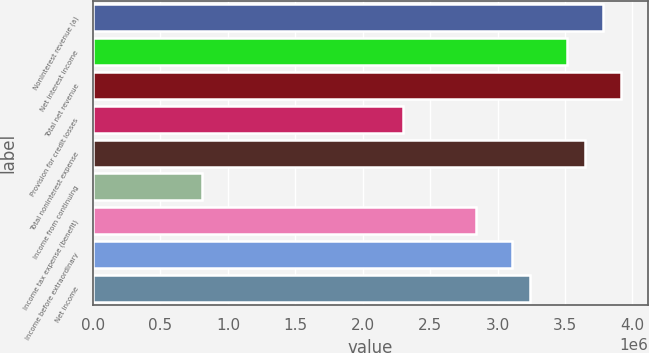Convert chart. <chart><loc_0><loc_0><loc_500><loc_500><bar_chart><fcel>Noninterest revenue (a)<fcel>Net interest income<fcel>Total net revenue<fcel>Provision for credit losses<fcel>Total noninterest expense<fcel>Income from continuing<fcel>Income tax expense (benefit)<fcel>Income before extraordinary<fcel>Net income<nl><fcel>3.78426e+06<fcel>3.51395e+06<fcel>3.91941e+06<fcel>2.29758e+06<fcel>3.6491e+06<fcel>810912<fcel>2.83819e+06<fcel>3.1085e+06<fcel>3.24365e+06<nl></chart> 